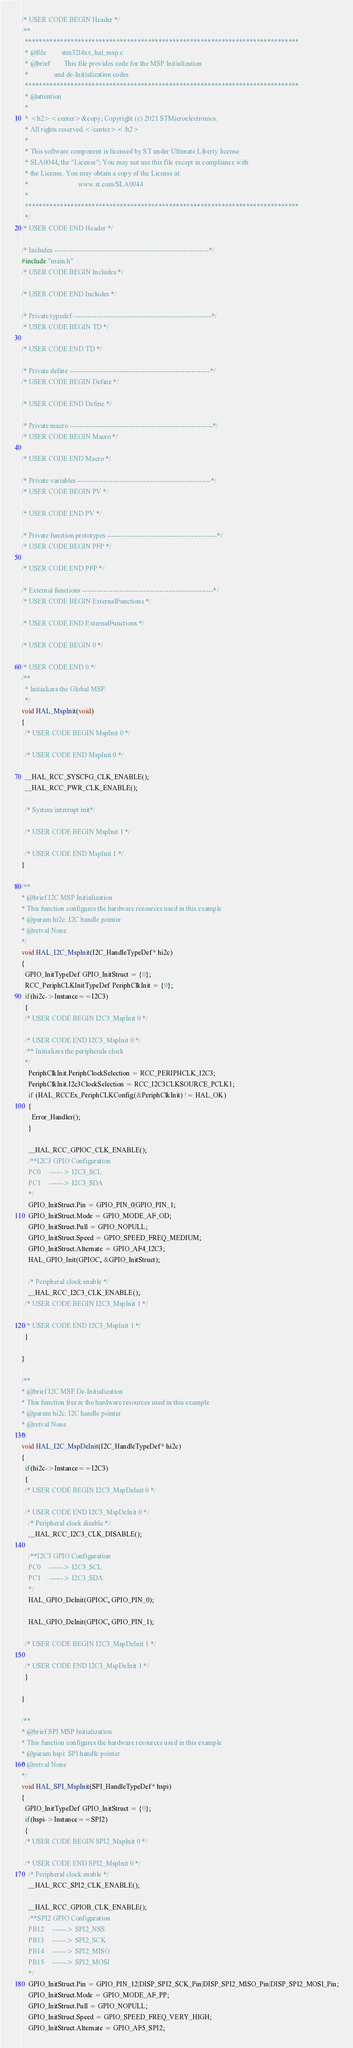Convert code to text. <code><loc_0><loc_0><loc_500><loc_500><_C_>/* USER CODE BEGIN Header */
/**
  ******************************************************************************
  * @file         stm32l4xx_hal_msp.c
  * @brief        This file provides code for the MSP Initialization
  *               and de-Initialization codes.
  ******************************************************************************
  * @attention
  *
  * <h2><center>&copy; Copyright (c) 2021 STMicroelectronics.
  * All rights reserved.</center></h2>
  *
  * This software component is licensed by ST under Ultimate Liberty license
  * SLA0044, the "License"; You may not use this file except in compliance with
  * the License. You may obtain a copy of the License at:
  *                             www.st.com/SLA0044
  *
  ******************************************************************************
  */
/* USER CODE END Header */

/* Includes ------------------------------------------------------------------*/
#include "main.h"
/* USER CODE BEGIN Includes */

/* USER CODE END Includes */

/* Private typedef -----------------------------------------------------------*/
/* USER CODE BEGIN TD */

/* USER CODE END TD */

/* Private define ------------------------------------------------------------*/
/* USER CODE BEGIN Define */

/* USER CODE END Define */

/* Private macro -------------------------------------------------------------*/
/* USER CODE BEGIN Macro */

/* USER CODE END Macro */

/* Private variables ---------------------------------------------------------*/
/* USER CODE BEGIN PV */

/* USER CODE END PV */

/* Private function prototypes -----------------------------------------------*/
/* USER CODE BEGIN PFP */

/* USER CODE END PFP */

/* External functions --------------------------------------------------------*/
/* USER CODE BEGIN ExternalFunctions */

/* USER CODE END ExternalFunctions */

/* USER CODE BEGIN 0 */

/* USER CODE END 0 */
/**
  * Initializes the Global MSP.
  */
void HAL_MspInit(void)
{
  /* USER CODE BEGIN MspInit 0 */

  /* USER CODE END MspInit 0 */

  __HAL_RCC_SYSCFG_CLK_ENABLE();
  __HAL_RCC_PWR_CLK_ENABLE();

  /* System interrupt init*/

  /* USER CODE BEGIN MspInit 1 */

  /* USER CODE END MspInit 1 */
}

/**
* @brief I2C MSP Initialization
* This function configures the hardware resources used in this example
* @param hi2c: I2C handle pointer
* @retval None
*/
void HAL_I2C_MspInit(I2C_HandleTypeDef* hi2c)
{
  GPIO_InitTypeDef GPIO_InitStruct = {0};
  RCC_PeriphCLKInitTypeDef PeriphClkInit = {0};
  if(hi2c->Instance==I2C3)
  {
  /* USER CODE BEGIN I2C3_MspInit 0 */

  /* USER CODE END I2C3_MspInit 0 */
  /** Initializes the peripherals clock
  */
    PeriphClkInit.PeriphClockSelection = RCC_PERIPHCLK_I2C3;
    PeriphClkInit.I2c3ClockSelection = RCC_I2C3CLKSOURCE_PCLK1;
    if (HAL_RCCEx_PeriphCLKConfig(&PeriphClkInit) != HAL_OK)
    {
      Error_Handler();
    }

    __HAL_RCC_GPIOC_CLK_ENABLE();
    /**I2C3 GPIO Configuration
    PC0     ------> I2C3_SCL
    PC1     ------> I2C3_SDA
    */
    GPIO_InitStruct.Pin = GPIO_PIN_0|GPIO_PIN_1;
    GPIO_InitStruct.Mode = GPIO_MODE_AF_OD;
    GPIO_InitStruct.Pull = GPIO_NOPULL;
    GPIO_InitStruct.Speed = GPIO_SPEED_FREQ_MEDIUM;
    GPIO_InitStruct.Alternate = GPIO_AF4_I2C3;
    HAL_GPIO_Init(GPIOC, &GPIO_InitStruct);

    /* Peripheral clock enable */
    __HAL_RCC_I2C3_CLK_ENABLE();
  /* USER CODE BEGIN I2C3_MspInit 1 */

  /* USER CODE END I2C3_MspInit 1 */
  }

}

/**
* @brief I2C MSP De-Initialization
* This function freeze the hardware resources used in this example
* @param hi2c: I2C handle pointer
* @retval None
*/
void HAL_I2C_MspDeInit(I2C_HandleTypeDef* hi2c)
{
  if(hi2c->Instance==I2C3)
  {
  /* USER CODE BEGIN I2C3_MspDeInit 0 */

  /* USER CODE END I2C3_MspDeInit 0 */
    /* Peripheral clock disable */
    __HAL_RCC_I2C3_CLK_DISABLE();

    /**I2C3 GPIO Configuration
    PC0     ------> I2C3_SCL
    PC1     ------> I2C3_SDA
    */
    HAL_GPIO_DeInit(GPIOC, GPIO_PIN_0);

    HAL_GPIO_DeInit(GPIOC, GPIO_PIN_1);

  /* USER CODE BEGIN I2C3_MspDeInit 1 */

  /* USER CODE END I2C3_MspDeInit 1 */
  }

}

/**
* @brief SPI MSP Initialization
* This function configures the hardware resources used in this example
* @param hspi: SPI handle pointer
* @retval None
*/
void HAL_SPI_MspInit(SPI_HandleTypeDef* hspi)
{
  GPIO_InitTypeDef GPIO_InitStruct = {0};
  if(hspi->Instance==SPI2)
  {
  /* USER CODE BEGIN SPI2_MspInit 0 */

  /* USER CODE END SPI2_MspInit 0 */
    /* Peripheral clock enable */
    __HAL_RCC_SPI2_CLK_ENABLE();

    __HAL_RCC_GPIOB_CLK_ENABLE();
    /**SPI2 GPIO Configuration
    PB12     ------> SPI2_NSS
    PB13     ------> SPI2_SCK
    PB14     ------> SPI2_MISO
    PB15     ------> SPI2_MOSI
    */
    GPIO_InitStruct.Pin = GPIO_PIN_12|DISP_SPI2_SCK_Pin|DISP_SPI2_MISO_Pin|DISP_SPI2_MOSI_Pin;
    GPIO_InitStruct.Mode = GPIO_MODE_AF_PP;
    GPIO_InitStruct.Pull = GPIO_NOPULL;
    GPIO_InitStruct.Speed = GPIO_SPEED_FREQ_VERY_HIGH;
    GPIO_InitStruct.Alternate = GPIO_AF5_SPI2;</code> 